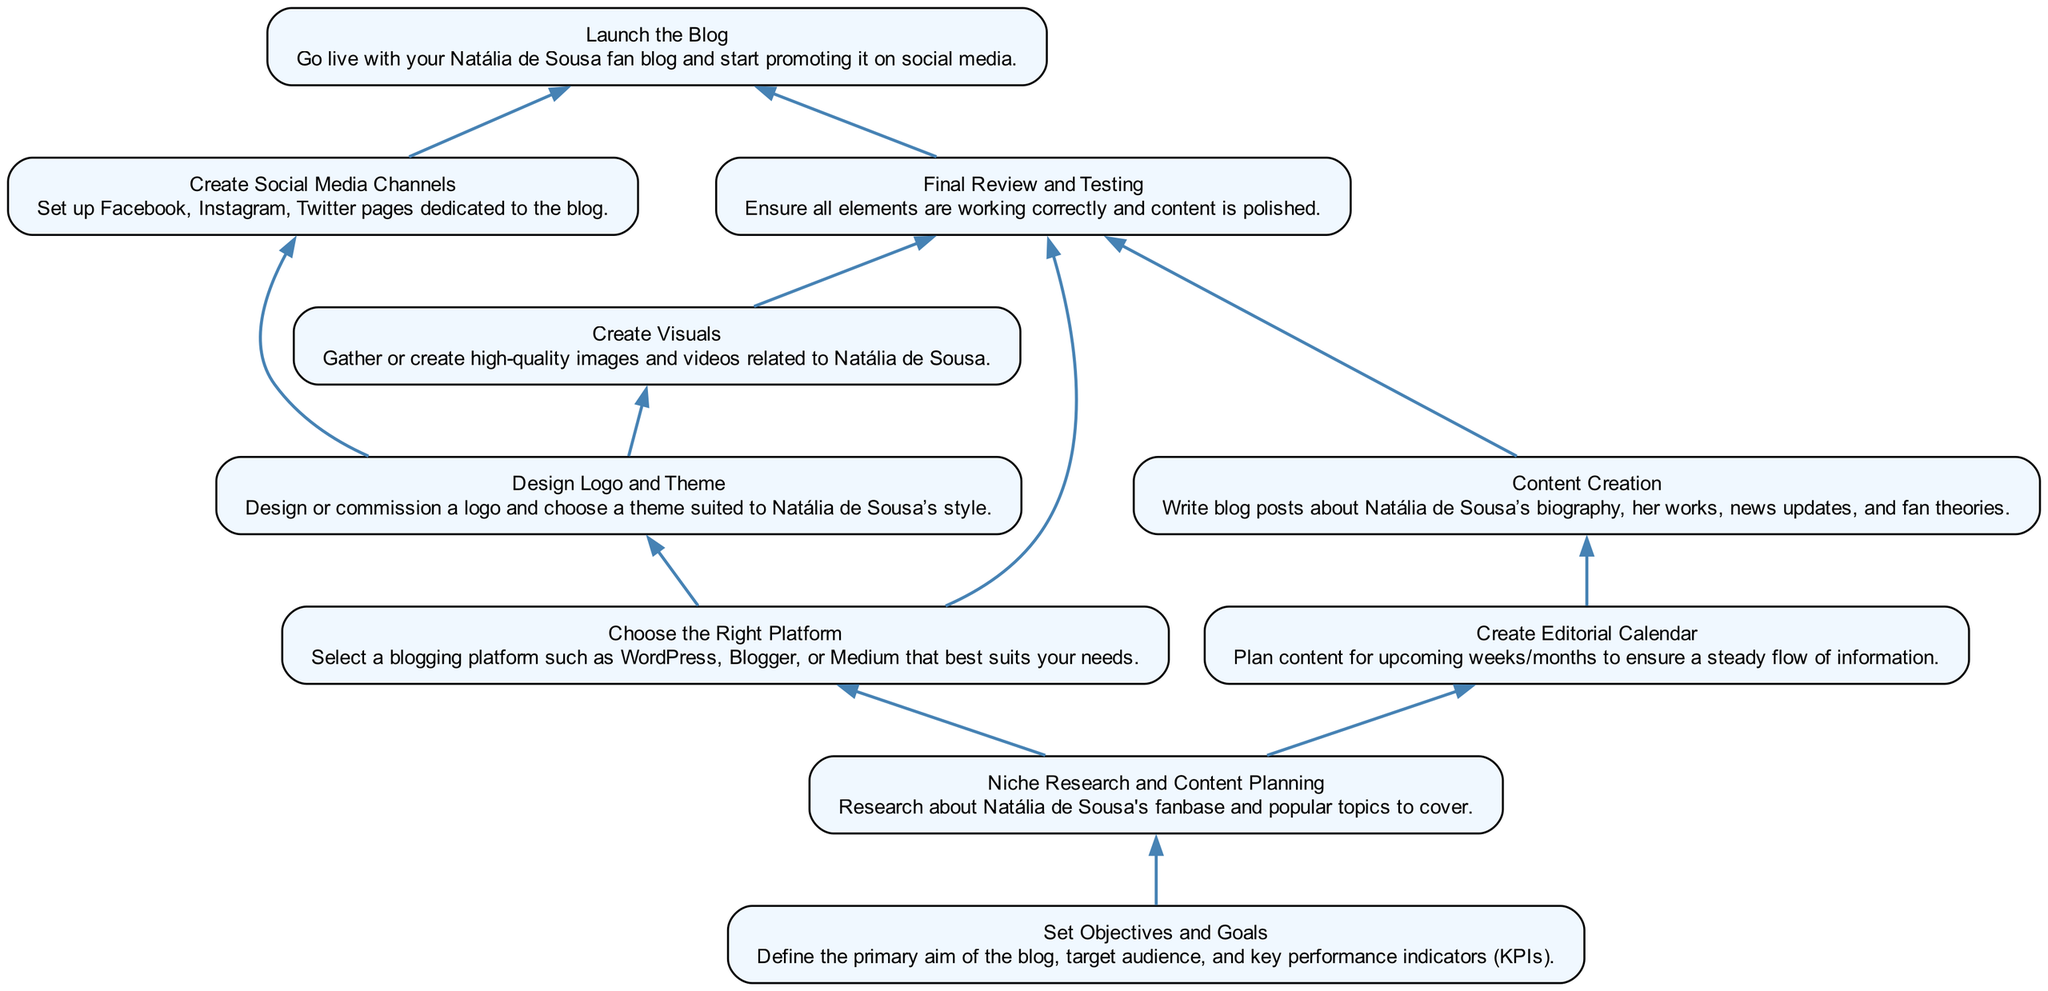What is the first step in creating the blog? The first step in the flow chart is "Set Objectives and Goals," as it does not depend on any previous action and is located at the bottom of the diagram.
Answer: Set Objectives and Goals How many total steps are there in the process? By counting the number of unique elements listed in the flow chart, there are 10 distinct steps involved in creating the blog.
Answer: 10 What is the last step that must be completed before launching the blog? According to the flow chart, the last step before "Launch the Blog" is "Final Review and Testing," as it is directly linked to the launch and appears just above it.
Answer: Final Review and Testing Which step involves planning content for upcoming weeks? The step "Create Editorial Calendar" is responsible for planning content, as indicated in the flow chart. This step comes after "Niche Research and Content Planning."
Answer: Create Editorial Calendar What are the dependencies for "Create Visuals"? The dependencies for "Create Visuals" are "Design Logo and Theme," as illustrated in the diagram where "Create Visuals" points from it.
Answer: Design Logo and Theme Before choosing the right platform, what should be done? "Niche Research and Content Planning" must be completed prior to "Choose the Right Platform," as shown in the flow chart where the former is a prerequisite of the latter.
Answer: Niche Research and Content Planning How many dependencies does "Content Creation" have? "Content Creation" has one dependency, which is "Create Editorial Calendar," as indicated by the single arrow pointing from the editorial calendar to content creation in the diagram.
Answer: 1 Which step directly leads to creating social media channels? The step "Design Logo and Theme" directly leads to "Create Social Media Channels," as evidenced by the flow of dependencies in the chart.
Answer: Design Logo and Theme What is essential to ensure before launching the blog? Ensuring that "Final Review and Testing" is completed is vital before launching the blog, as it is the necessary step immediately preceding the launch in the flow.
Answer: Final Review and Testing 